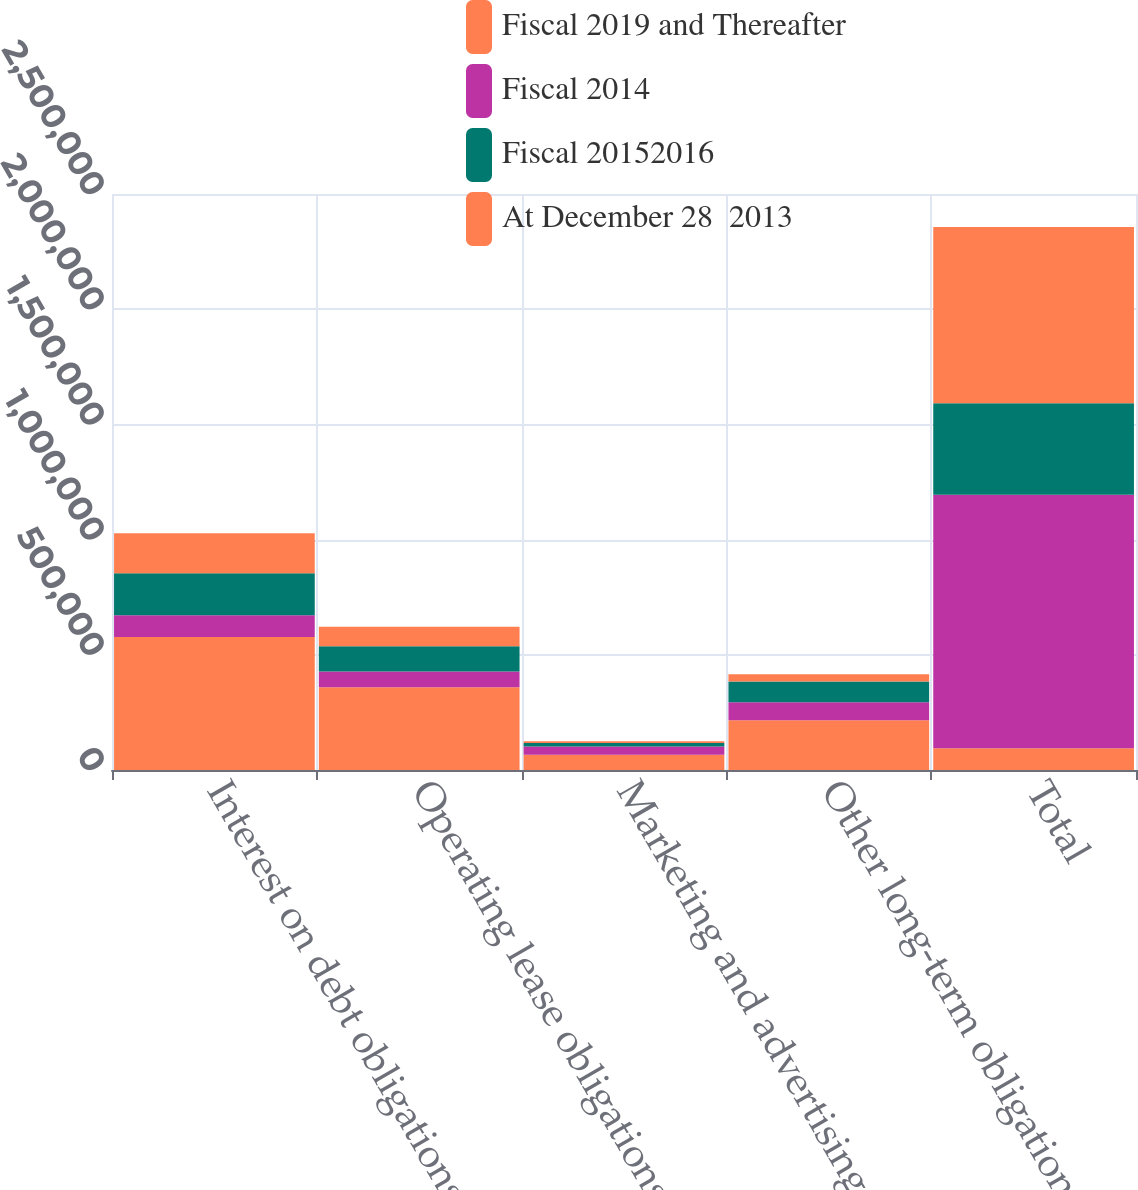Convert chart. <chart><loc_0><loc_0><loc_500><loc_500><stacked_bar_chart><ecel><fcel>Interest on debt obligations<fcel>Operating lease obligations<fcel>Marketing and advertising<fcel>Other long-term obligations<fcel>Total<nl><fcel>Fiscal 2019 and Thereafter<fcel>577486<fcel>358960<fcel>66318<fcel>216183<fcel>94153<nl><fcel>Fiscal 2014<fcel>94153<fcel>68127<fcel>35837<fcel>77505<fcel>1.10059e+06<nl><fcel>Fiscal 20152016<fcel>182500<fcel>109877<fcel>14751<fcel>90450<fcel>397578<nl><fcel>At December 28  2013<fcel>173333<fcel>85084<fcel>7517<fcel>31192<fcel>764126<nl></chart> 